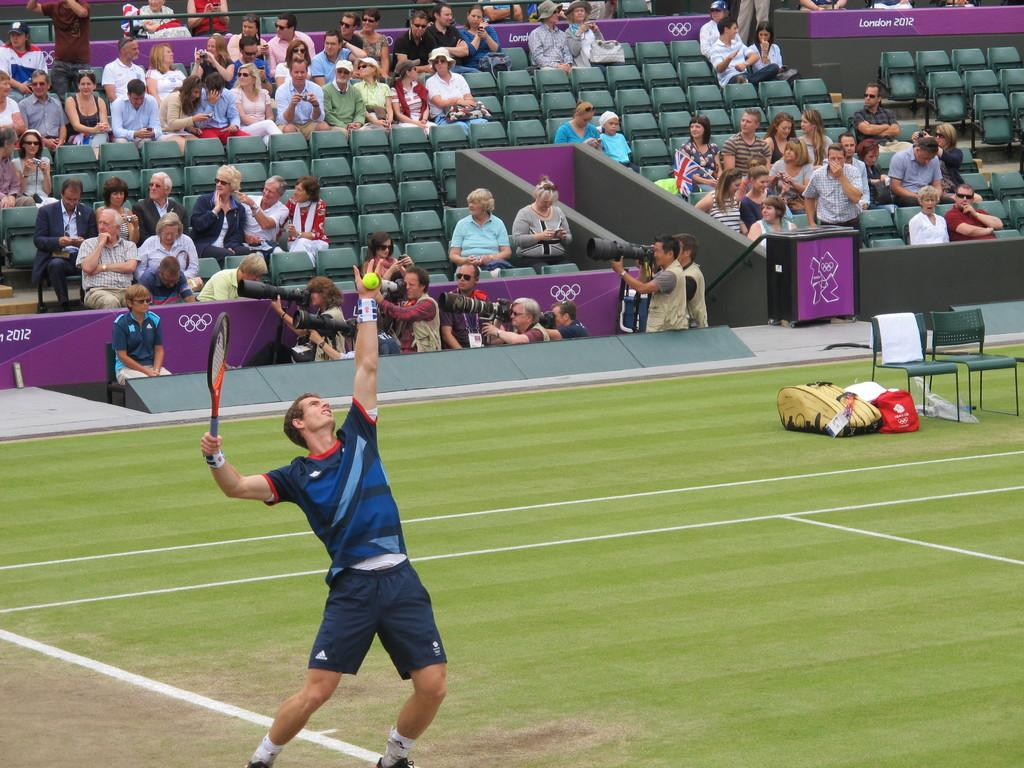Provide a one-sentence caption for the provided image. Man about to serve a tennis ball while wearing Adidas shorts. 